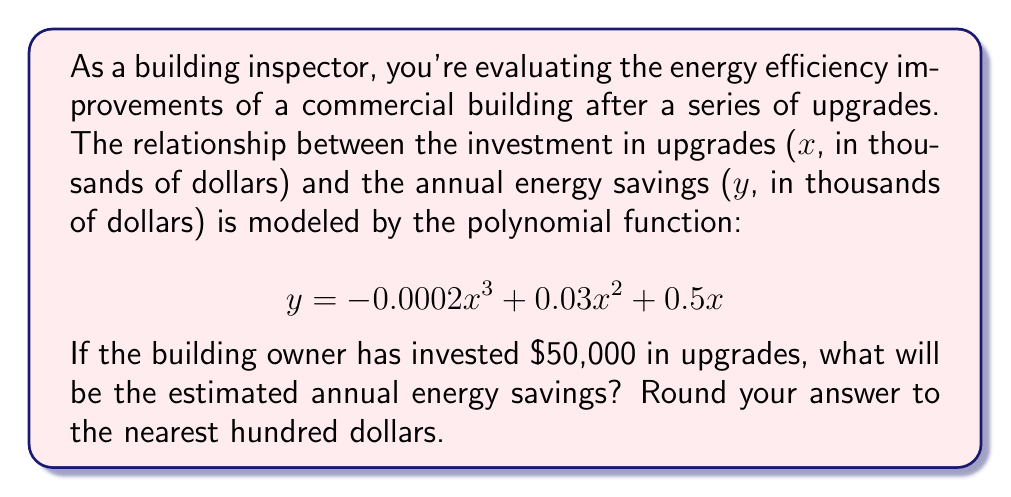Could you help me with this problem? To solve this problem, we need to follow these steps:

1) We're given the polynomial function:
   $$ y = -0.0002x^3 + 0.03x^2 + 0.5x $$

2) The investment is $50,000, which is 50 when expressed in thousands of dollars. So we need to calculate y when x = 50.

3) Let's substitute x = 50 into the equation:
   $$ y = -0.0002(50)^3 + 0.03(50)^2 + 0.5(50) $$

4) Now let's calculate each term:
   - $-0.0002(50)^3 = -0.0002 * 125000 = -25$
   - $0.03(50)^2 = 0.03 * 2500 = 75$
   - $0.5(50) = 25$

5) Sum up all terms:
   $$ y = -25 + 75 + 25 = 75 $$

6) The result, 75, is in thousands of dollars. So the actual amount is $75,000.

7) Rounding to the nearest hundred dollars gives us $75,000.
Answer: $75,000 